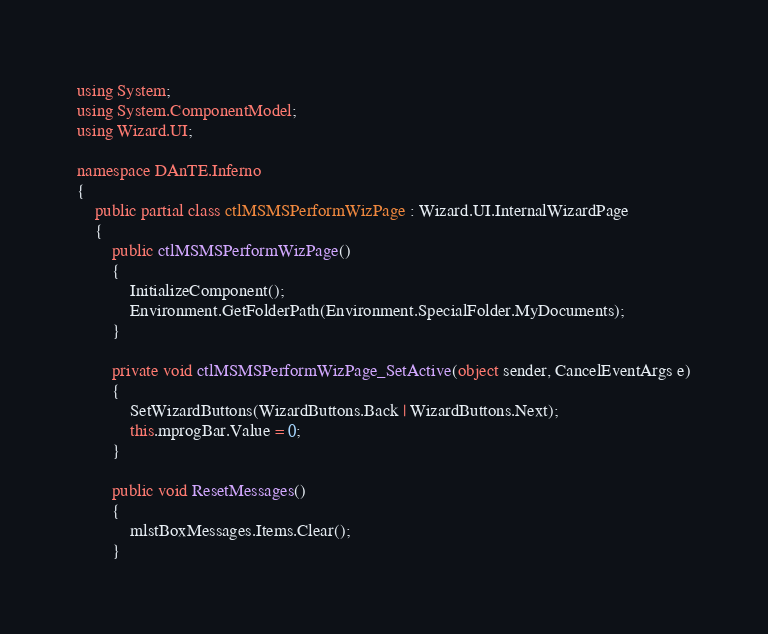<code> <loc_0><loc_0><loc_500><loc_500><_C#_>using System;
using System.ComponentModel;
using Wizard.UI;

namespace DAnTE.Inferno
{
    public partial class ctlMSMSPerformWizPage : Wizard.UI.InternalWizardPage
    {
        public ctlMSMSPerformWizPage()
        {
            InitializeComponent();
            Environment.GetFolderPath(Environment.SpecialFolder.MyDocuments);
        }

        private void ctlMSMSPerformWizPage_SetActive(object sender, CancelEventArgs e)
        {
            SetWizardButtons(WizardButtons.Back | WizardButtons.Next);
            this.mprogBar.Value = 0;
        }

        public void ResetMessages()
        {
            mlstBoxMessages.Items.Clear();
        }
</code> 